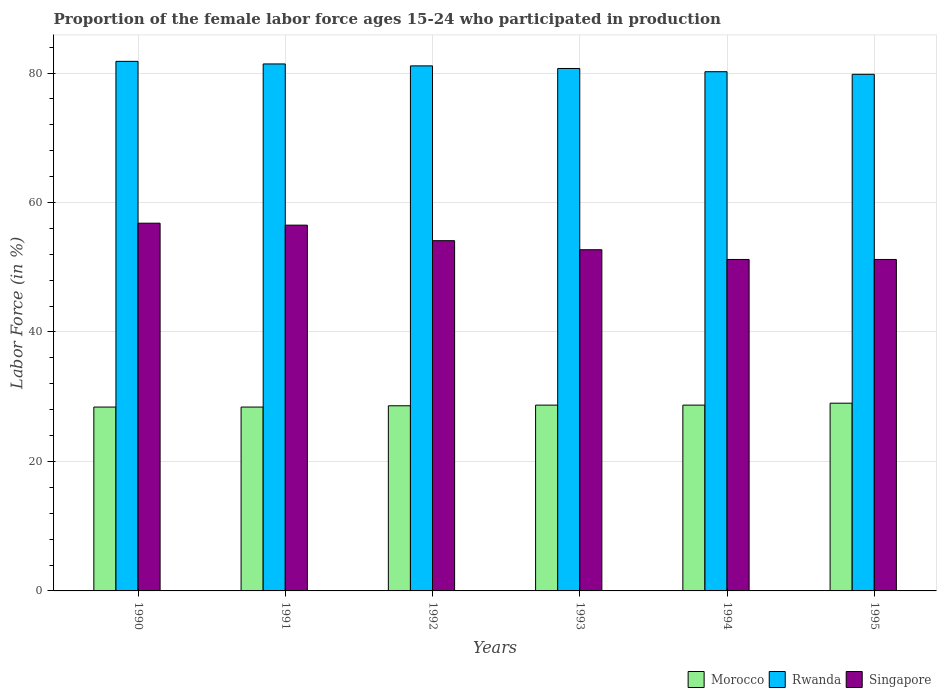How many different coloured bars are there?
Keep it short and to the point. 3. How many groups of bars are there?
Your answer should be compact. 6. Are the number of bars per tick equal to the number of legend labels?
Your answer should be very brief. Yes. Are the number of bars on each tick of the X-axis equal?
Give a very brief answer. Yes. Across all years, what is the maximum proportion of the female labor force who participated in production in Rwanda?
Your response must be concise. 81.8. Across all years, what is the minimum proportion of the female labor force who participated in production in Morocco?
Provide a succinct answer. 28.4. In which year was the proportion of the female labor force who participated in production in Singapore maximum?
Make the answer very short. 1990. In which year was the proportion of the female labor force who participated in production in Singapore minimum?
Your answer should be compact. 1994. What is the total proportion of the female labor force who participated in production in Morocco in the graph?
Your response must be concise. 171.8. What is the difference between the proportion of the female labor force who participated in production in Rwanda in 1992 and that in 1995?
Give a very brief answer. 1.3. What is the difference between the proportion of the female labor force who participated in production in Morocco in 1992 and the proportion of the female labor force who participated in production in Singapore in 1995?
Provide a short and direct response. -22.6. What is the average proportion of the female labor force who participated in production in Singapore per year?
Give a very brief answer. 53.75. In the year 1995, what is the difference between the proportion of the female labor force who participated in production in Singapore and proportion of the female labor force who participated in production in Rwanda?
Provide a succinct answer. -28.6. In how many years, is the proportion of the female labor force who participated in production in Singapore greater than 72 %?
Ensure brevity in your answer.  0. What is the ratio of the proportion of the female labor force who participated in production in Singapore in 1992 to that in 1993?
Keep it short and to the point. 1.03. Is the proportion of the female labor force who participated in production in Morocco in 1990 less than that in 1994?
Your response must be concise. Yes. What is the difference between the highest and the second highest proportion of the female labor force who participated in production in Singapore?
Your answer should be compact. 0.3. What is the difference between the highest and the lowest proportion of the female labor force who participated in production in Singapore?
Provide a succinct answer. 5.6. In how many years, is the proportion of the female labor force who participated in production in Rwanda greater than the average proportion of the female labor force who participated in production in Rwanda taken over all years?
Give a very brief answer. 3. What does the 2nd bar from the left in 1991 represents?
Offer a terse response. Rwanda. What does the 1st bar from the right in 1990 represents?
Your response must be concise. Singapore. Are all the bars in the graph horizontal?
Offer a very short reply. No. What is the difference between two consecutive major ticks on the Y-axis?
Provide a short and direct response. 20. Does the graph contain grids?
Your answer should be very brief. Yes. How many legend labels are there?
Your response must be concise. 3. What is the title of the graph?
Make the answer very short. Proportion of the female labor force ages 15-24 who participated in production. Does "Jamaica" appear as one of the legend labels in the graph?
Provide a short and direct response. No. What is the label or title of the X-axis?
Give a very brief answer. Years. What is the label or title of the Y-axis?
Provide a succinct answer. Labor Force (in %). What is the Labor Force (in %) in Morocco in 1990?
Provide a succinct answer. 28.4. What is the Labor Force (in %) in Rwanda in 1990?
Offer a terse response. 81.8. What is the Labor Force (in %) in Singapore in 1990?
Your response must be concise. 56.8. What is the Labor Force (in %) in Morocco in 1991?
Make the answer very short. 28.4. What is the Labor Force (in %) of Rwanda in 1991?
Provide a succinct answer. 81.4. What is the Labor Force (in %) in Singapore in 1991?
Provide a short and direct response. 56.5. What is the Labor Force (in %) in Morocco in 1992?
Your response must be concise. 28.6. What is the Labor Force (in %) of Rwanda in 1992?
Ensure brevity in your answer.  81.1. What is the Labor Force (in %) in Singapore in 1992?
Provide a short and direct response. 54.1. What is the Labor Force (in %) in Morocco in 1993?
Your response must be concise. 28.7. What is the Labor Force (in %) in Rwanda in 1993?
Ensure brevity in your answer.  80.7. What is the Labor Force (in %) of Singapore in 1993?
Provide a short and direct response. 52.7. What is the Labor Force (in %) of Morocco in 1994?
Provide a short and direct response. 28.7. What is the Labor Force (in %) in Rwanda in 1994?
Ensure brevity in your answer.  80.2. What is the Labor Force (in %) in Singapore in 1994?
Ensure brevity in your answer.  51.2. What is the Labor Force (in %) in Morocco in 1995?
Offer a terse response. 29. What is the Labor Force (in %) in Rwanda in 1995?
Keep it short and to the point. 79.8. What is the Labor Force (in %) of Singapore in 1995?
Give a very brief answer. 51.2. Across all years, what is the maximum Labor Force (in %) in Rwanda?
Your response must be concise. 81.8. Across all years, what is the maximum Labor Force (in %) in Singapore?
Keep it short and to the point. 56.8. Across all years, what is the minimum Labor Force (in %) of Morocco?
Provide a succinct answer. 28.4. Across all years, what is the minimum Labor Force (in %) of Rwanda?
Give a very brief answer. 79.8. Across all years, what is the minimum Labor Force (in %) in Singapore?
Keep it short and to the point. 51.2. What is the total Labor Force (in %) of Morocco in the graph?
Your response must be concise. 171.8. What is the total Labor Force (in %) of Rwanda in the graph?
Give a very brief answer. 485. What is the total Labor Force (in %) in Singapore in the graph?
Offer a terse response. 322.5. What is the difference between the Labor Force (in %) of Rwanda in 1990 and that in 1991?
Your answer should be compact. 0.4. What is the difference between the Labor Force (in %) in Singapore in 1990 and that in 1992?
Offer a terse response. 2.7. What is the difference between the Labor Force (in %) in Morocco in 1990 and that in 1993?
Your response must be concise. -0.3. What is the difference between the Labor Force (in %) in Rwanda in 1990 and that in 1993?
Your answer should be compact. 1.1. What is the difference between the Labor Force (in %) of Singapore in 1990 and that in 1993?
Ensure brevity in your answer.  4.1. What is the difference between the Labor Force (in %) in Morocco in 1990 and that in 1995?
Offer a very short reply. -0.6. What is the difference between the Labor Force (in %) in Singapore in 1990 and that in 1995?
Provide a succinct answer. 5.6. What is the difference between the Labor Force (in %) in Rwanda in 1991 and that in 1992?
Provide a short and direct response. 0.3. What is the difference between the Labor Force (in %) of Rwanda in 1991 and that in 1993?
Your answer should be very brief. 0.7. What is the difference between the Labor Force (in %) of Singapore in 1991 and that in 1993?
Provide a short and direct response. 3.8. What is the difference between the Labor Force (in %) of Rwanda in 1991 and that in 1994?
Keep it short and to the point. 1.2. What is the difference between the Labor Force (in %) of Singapore in 1991 and that in 1994?
Offer a terse response. 5.3. What is the difference between the Labor Force (in %) of Morocco in 1991 and that in 1995?
Your response must be concise. -0.6. What is the difference between the Labor Force (in %) in Rwanda in 1991 and that in 1995?
Provide a short and direct response. 1.6. What is the difference between the Labor Force (in %) of Rwanda in 1992 and that in 1993?
Provide a short and direct response. 0.4. What is the difference between the Labor Force (in %) of Morocco in 1992 and that in 1995?
Give a very brief answer. -0.4. What is the difference between the Labor Force (in %) of Rwanda in 1992 and that in 1995?
Your answer should be very brief. 1.3. What is the difference between the Labor Force (in %) of Singapore in 1992 and that in 1995?
Provide a succinct answer. 2.9. What is the difference between the Labor Force (in %) in Morocco in 1993 and that in 1994?
Offer a very short reply. 0. What is the difference between the Labor Force (in %) in Singapore in 1993 and that in 1994?
Make the answer very short. 1.5. What is the difference between the Labor Force (in %) of Rwanda in 1994 and that in 1995?
Offer a terse response. 0.4. What is the difference between the Labor Force (in %) of Morocco in 1990 and the Labor Force (in %) of Rwanda in 1991?
Keep it short and to the point. -53. What is the difference between the Labor Force (in %) of Morocco in 1990 and the Labor Force (in %) of Singapore in 1991?
Provide a short and direct response. -28.1. What is the difference between the Labor Force (in %) of Rwanda in 1990 and the Labor Force (in %) of Singapore in 1991?
Offer a terse response. 25.3. What is the difference between the Labor Force (in %) in Morocco in 1990 and the Labor Force (in %) in Rwanda in 1992?
Give a very brief answer. -52.7. What is the difference between the Labor Force (in %) in Morocco in 1990 and the Labor Force (in %) in Singapore in 1992?
Your response must be concise. -25.7. What is the difference between the Labor Force (in %) of Rwanda in 1990 and the Labor Force (in %) of Singapore in 1992?
Your answer should be very brief. 27.7. What is the difference between the Labor Force (in %) in Morocco in 1990 and the Labor Force (in %) in Rwanda in 1993?
Your response must be concise. -52.3. What is the difference between the Labor Force (in %) in Morocco in 1990 and the Labor Force (in %) in Singapore in 1993?
Offer a terse response. -24.3. What is the difference between the Labor Force (in %) of Rwanda in 1990 and the Labor Force (in %) of Singapore in 1993?
Provide a short and direct response. 29.1. What is the difference between the Labor Force (in %) of Morocco in 1990 and the Labor Force (in %) of Rwanda in 1994?
Your response must be concise. -51.8. What is the difference between the Labor Force (in %) of Morocco in 1990 and the Labor Force (in %) of Singapore in 1994?
Offer a terse response. -22.8. What is the difference between the Labor Force (in %) of Rwanda in 1990 and the Labor Force (in %) of Singapore in 1994?
Your answer should be compact. 30.6. What is the difference between the Labor Force (in %) in Morocco in 1990 and the Labor Force (in %) in Rwanda in 1995?
Provide a short and direct response. -51.4. What is the difference between the Labor Force (in %) in Morocco in 1990 and the Labor Force (in %) in Singapore in 1995?
Ensure brevity in your answer.  -22.8. What is the difference between the Labor Force (in %) in Rwanda in 1990 and the Labor Force (in %) in Singapore in 1995?
Make the answer very short. 30.6. What is the difference between the Labor Force (in %) in Morocco in 1991 and the Labor Force (in %) in Rwanda in 1992?
Keep it short and to the point. -52.7. What is the difference between the Labor Force (in %) in Morocco in 1991 and the Labor Force (in %) in Singapore in 1992?
Ensure brevity in your answer.  -25.7. What is the difference between the Labor Force (in %) of Rwanda in 1991 and the Labor Force (in %) of Singapore in 1992?
Your answer should be compact. 27.3. What is the difference between the Labor Force (in %) in Morocco in 1991 and the Labor Force (in %) in Rwanda in 1993?
Ensure brevity in your answer.  -52.3. What is the difference between the Labor Force (in %) of Morocco in 1991 and the Labor Force (in %) of Singapore in 1993?
Ensure brevity in your answer.  -24.3. What is the difference between the Labor Force (in %) of Rwanda in 1991 and the Labor Force (in %) of Singapore in 1993?
Ensure brevity in your answer.  28.7. What is the difference between the Labor Force (in %) in Morocco in 1991 and the Labor Force (in %) in Rwanda in 1994?
Offer a terse response. -51.8. What is the difference between the Labor Force (in %) of Morocco in 1991 and the Labor Force (in %) of Singapore in 1994?
Your answer should be compact. -22.8. What is the difference between the Labor Force (in %) in Rwanda in 1991 and the Labor Force (in %) in Singapore in 1994?
Your answer should be very brief. 30.2. What is the difference between the Labor Force (in %) of Morocco in 1991 and the Labor Force (in %) of Rwanda in 1995?
Offer a very short reply. -51.4. What is the difference between the Labor Force (in %) in Morocco in 1991 and the Labor Force (in %) in Singapore in 1995?
Keep it short and to the point. -22.8. What is the difference between the Labor Force (in %) in Rwanda in 1991 and the Labor Force (in %) in Singapore in 1995?
Make the answer very short. 30.2. What is the difference between the Labor Force (in %) in Morocco in 1992 and the Labor Force (in %) in Rwanda in 1993?
Your answer should be very brief. -52.1. What is the difference between the Labor Force (in %) in Morocco in 1992 and the Labor Force (in %) in Singapore in 1993?
Keep it short and to the point. -24.1. What is the difference between the Labor Force (in %) of Rwanda in 1992 and the Labor Force (in %) of Singapore in 1993?
Make the answer very short. 28.4. What is the difference between the Labor Force (in %) in Morocco in 1992 and the Labor Force (in %) in Rwanda in 1994?
Provide a short and direct response. -51.6. What is the difference between the Labor Force (in %) of Morocco in 1992 and the Labor Force (in %) of Singapore in 1994?
Provide a succinct answer. -22.6. What is the difference between the Labor Force (in %) in Rwanda in 1992 and the Labor Force (in %) in Singapore in 1994?
Offer a very short reply. 29.9. What is the difference between the Labor Force (in %) in Morocco in 1992 and the Labor Force (in %) in Rwanda in 1995?
Offer a very short reply. -51.2. What is the difference between the Labor Force (in %) of Morocco in 1992 and the Labor Force (in %) of Singapore in 1995?
Offer a very short reply. -22.6. What is the difference between the Labor Force (in %) in Rwanda in 1992 and the Labor Force (in %) in Singapore in 1995?
Your answer should be very brief. 29.9. What is the difference between the Labor Force (in %) of Morocco in 1993 and the Labor Force (in %) of Rwanda in 1994?
Your answer should be very brief. -51.5. What is the difference between the Labor Force (in %) of Morocco in 1993 and the Labor Force (in %) of Singapore in 1994?
Make the answer very short. -22.5. What is the difference between the Labor Force (in %) in Rwanda in 1993 and the Labor Force (in %) in Singapore in 1994?
Provide a succinct answer. 29.5. What is the difference between the Labor Force (in %) of Morocco in 1993 and the Labor Force (in %) of Rwanda in 1995?
Your response must be concise. -51.1. What is the difference between the Labor Force (in %) in Morocco in 1993 and the Labor Force (in %) in Singapore in 1995?
Ensure brevity in your answer.  -22.5. What is the difference between the Labor Force (in %) in Rwanda in 1993 and the Labor Force (in %) in Singapore in 1995?
Ensure brevity in your answer.  29.5. What is the difference between the Labor Force (in %) of Morocco in 1994 and the Labor Force (in %) of Rwanda in 1995?
Your response must be concise. -51.1. What is the difference between the Labor Force (in %) of Morocco in 1994 and the Labor Force (in %) of Singapore in 1995?
Keep it short and to the point. -22.5. What is the average Labor Force (in %) in Morocco per year?
Your response must be concise. 28.63. What is the average Labor Force (in %) in Rwanda per year?
Provide a succinct answer. 80.83. What is the average Labor Force (in %) of Singapore per year?
Offer a terse response. 53.75. In the year 1990, what is the difference between the Labor Force (in %) in Morocco and Labor Force (in %) in Rwanda?
Keep it short and to the point. -53.4. In the year 1990, what is the difference between the Labor Force (in %) of Morocco and Labor Force (in %) of Singapore?
Keep it short and to the point. -28.4. In the year 1990, what is the difference between the Labor Force (in %) of Rwanda and Labor Force (in %) of Singapore?
Keep it short and to the point. 25. In the year 1991, what is the difference between the Labor Force (in %) in Morocco and Labor Force (in %) in Rwanda?
Offer a very short reply. -53. In the year 1991, what is the difference between the Labor Force (in %) of Morocco and Labor Force (in %) of Singapore?
Give a very brief answer. -28.1. In the year 1991, what is the difference between the Labor Force (in %) in Rwanda and Labor Force (in %) in Singapore?
Give a very brief answer. 24.9. In the year 1992, what is the difference between the Labor Force (in %) in Morocco and Labor Force (in %) in Rwanda?
Provide a succinct answer. -52.5. In the year 1992, what is the difference between the Labor Force (in %) of Morocco and Labor Force (in %) of Singapore?
Offer a terse response. -25.5. In the year 1993, what is the difference between the Labor Force (in %) of Morocco and Labor Force (in %) of Rwanda?
Provide a succinct answer. -52. In the year 1994, what is the difference between the Labor Force (in %) in Morocco and Labor Force (in %) in Rwanda?
Ensure brevity in your answer.  -51.5. In the year 1994, what is the difference between the Labor Force (in %) of Morocco and Labor Force (in %) of Singapore?
Provide a succinct answer. -22.5. In the year 1995, what is the difference between the Labor Force (in %) of Morocco and Labor Force (in %) of Rwanda?
Offer a very short reply. -50.8. In the year 1995, what is the difference between the Labor Force (in %) of Morocco and Labor Force (in %) of Singapore?
Your answer should be compact. -22.2. In the year 1995, what is the difference between the Labor Force (in %) in Rwanda and Labor Force (in %) in Singapore?
Offer a very short reply. 28.6. What is the ratio of the Labor Force (in %) in Morocco in 1990 to that in 1992?
Provide a succinct answer. 0.99. What is the ratio of the Labor Force (in %) of Rwanda in 1990 to that in 1992?
Offer a terse response. 1.01. What is the ratio of the Labor Force (in %) in Singapore in 1990 to that in 1992?
Your answer should be very brief. 1.05. What is the ratio of the Labor Force (in %) of Rwanda in 1990 to that in 1993?
Provide a succinct answer. 1.01. What is the ratio of the Labor Force (in %) in Singapore in 1990 to that in 1993?
Give a very brief answer. 1.08. What is the ratio of the Labor Force (in %) of Rwanda in 1990 to that in 1994?
Your answer should be very brief. 1.02. What is the ratio of the Labor Force (in %) of Singapore in 1990 to that in 1994?
Make the answer very short. 1.11. What is the ratio of the Labor Force (in %) in Morocco in 1990 to that in 1995?
Provide a succinct answer. 0.98. What is the ratio of the Labor Force (in %) in Rwanda in 1990 to that in 1995?
Ensure brevity in your answer.  1.03. What is the ratio of the Labor Force (in %) in Singapore in 1990 to that in 1995?
Your answer should be compact. 1.11. What is the ratio of the Labor Force (in %) in Morocco in 1991 to that in 1992?
Your response must be concise. 0.99. What is the ratio of the Labor Force (in %) of Singapore in 1991 to that in 1992?
Your answer should be very brief. 1.04. What is the ratio of the Labor Force (in %) of Morocco in 1991 to that in 1993?
Provide a succinct answer. 0.99. What is the ratio of the Labor Force (in %) of Rwanda in 1991 to that in 1993?
Keep it short and to the point. 1.01. What is the ratio of the Labor Force (in %) in Singapore in 1991 to that in 1993?
Make the answer very short. 1.07. What is the ratio of the Labor Force (in %) of Singapore in 1991 to that in 1994?
Provide a short and direct response. 1.1. What is the ratio of the Labor Force (in %) of Morocco in 1991 to that in 1995?
Offer a terse response. 0.98. What is the ratio of the Labor Force (in %) of Rwanda in 1991 to that in 1995?
Your answer should be compact. 1.02. What is the ratio of the Labor Force (in %) in Singapore in 1991 to that in 1995?
Ensure brevity in your answer.  1.1. What is the ratio of the Labor Force (in %) in Rwanda in 1992 to that in 1993?
Make the answer very short. 1. What is the ratio of the Labor Force (in %) in Singapore in 1992 to that in 1993?
Your response must be concise. 1.03. What is the ratio of the Labor Force (in %) in Morocco in 1992 to that in 1994?
Provide a short and direct response. 1. What is the ratio of the Labor Force (in %) in Rwanda in 1992 to that in 1994?
Provide a succinct answer. 1.01. What is the ratio of the Labor Force (in %) in Singapore in 1992 to that in 1994?
Give a very brief answer. 1.06. What is the ratio of the Labor Force (in %) in Morocco in 1992 to that in 1995?
Keep it short and to the point. 0.99. What is the ratio of the Labor Force (in %) in Rwanda in 1992 to that in 1995?
Provide a succinct answer. 1.02. What is the ratio of the Labor Force (in %) of Singapore in 1992 to that in 1995?
Give a very brief answer. 1.06. What is the ratio of the Labor Force (in %) in Rwanda in 1993 to that in 1994?
Your response must be concise. 1.01. What is the ratio of the Labor Force (in %) in Singapore in 1993 to that in 1994?
Your answer should be very brief. 1.03. What is the ratio of the Labor Force (in %) in Rwanda in 1993 to that in 1995?
Give a very brief answer. 1.01. What is the ratio of the Labor Force (in %) in Singapore in 1993 to that in 1995?
Offer a terse response. 1.03. What is the ratio of the Labor Force (in %) of Morocco in 1994 to that in 1995?
Your response must be concise. 0.99. What is the ratio of the Labor Force (in %) of Singapore in 1994 to that in 1995?
Your answer should be very brief. 1. What is the difference between the highest and the second highest Labor Force (in %) of Morocco?
Ensure brevity in your answer.  0.3. What is the difference between the highest and the second highest Labor Force (in %) of Rwanda?
Offer a very short reply. 0.4. What is the difference between the highest and the lowest Labor Force (in %) of Morocco?
Offer a terse response. 0.6. What is the difference between the highest and the lowest Labor Force (in %) in Singapore?
Offer a terse response. 5.6. 